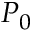<formula> <loc_0><loc_0><loc_500><loc_500>P _ { 0 }</formula> 